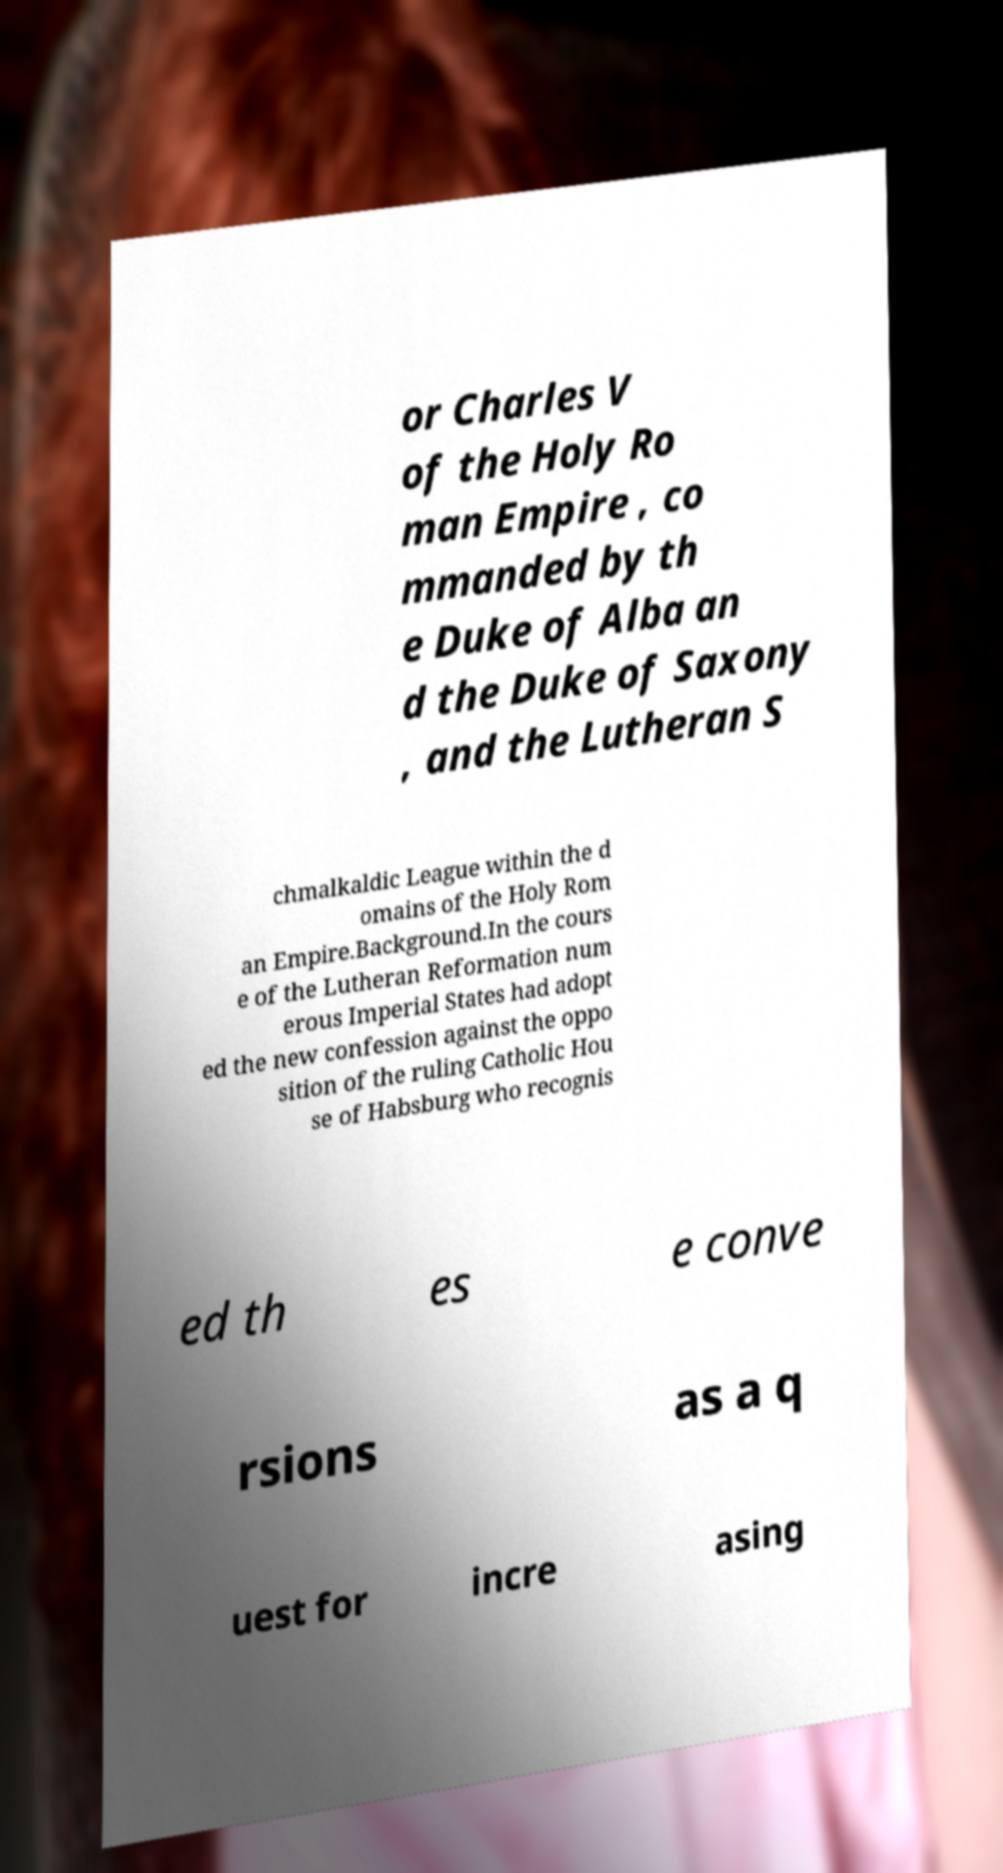Could you assist in decoding the text presented in this image and type it out clearly? or Charles V of the Holy Ro man Empire , co mmanded by th e Duke of Alba an d the Duke of Saxony , and the Lutheran S chmalkaldic League within the d omains of the Holy Rom an Empire.Background.In the cours e of the Lutheran Reformation num erous Imperial States had adopt ed the new confession against the oppo sition of the ruling Catholic Hou se of Habsburg who recognis ed th es e conve rsions as a q uest for incre asing 